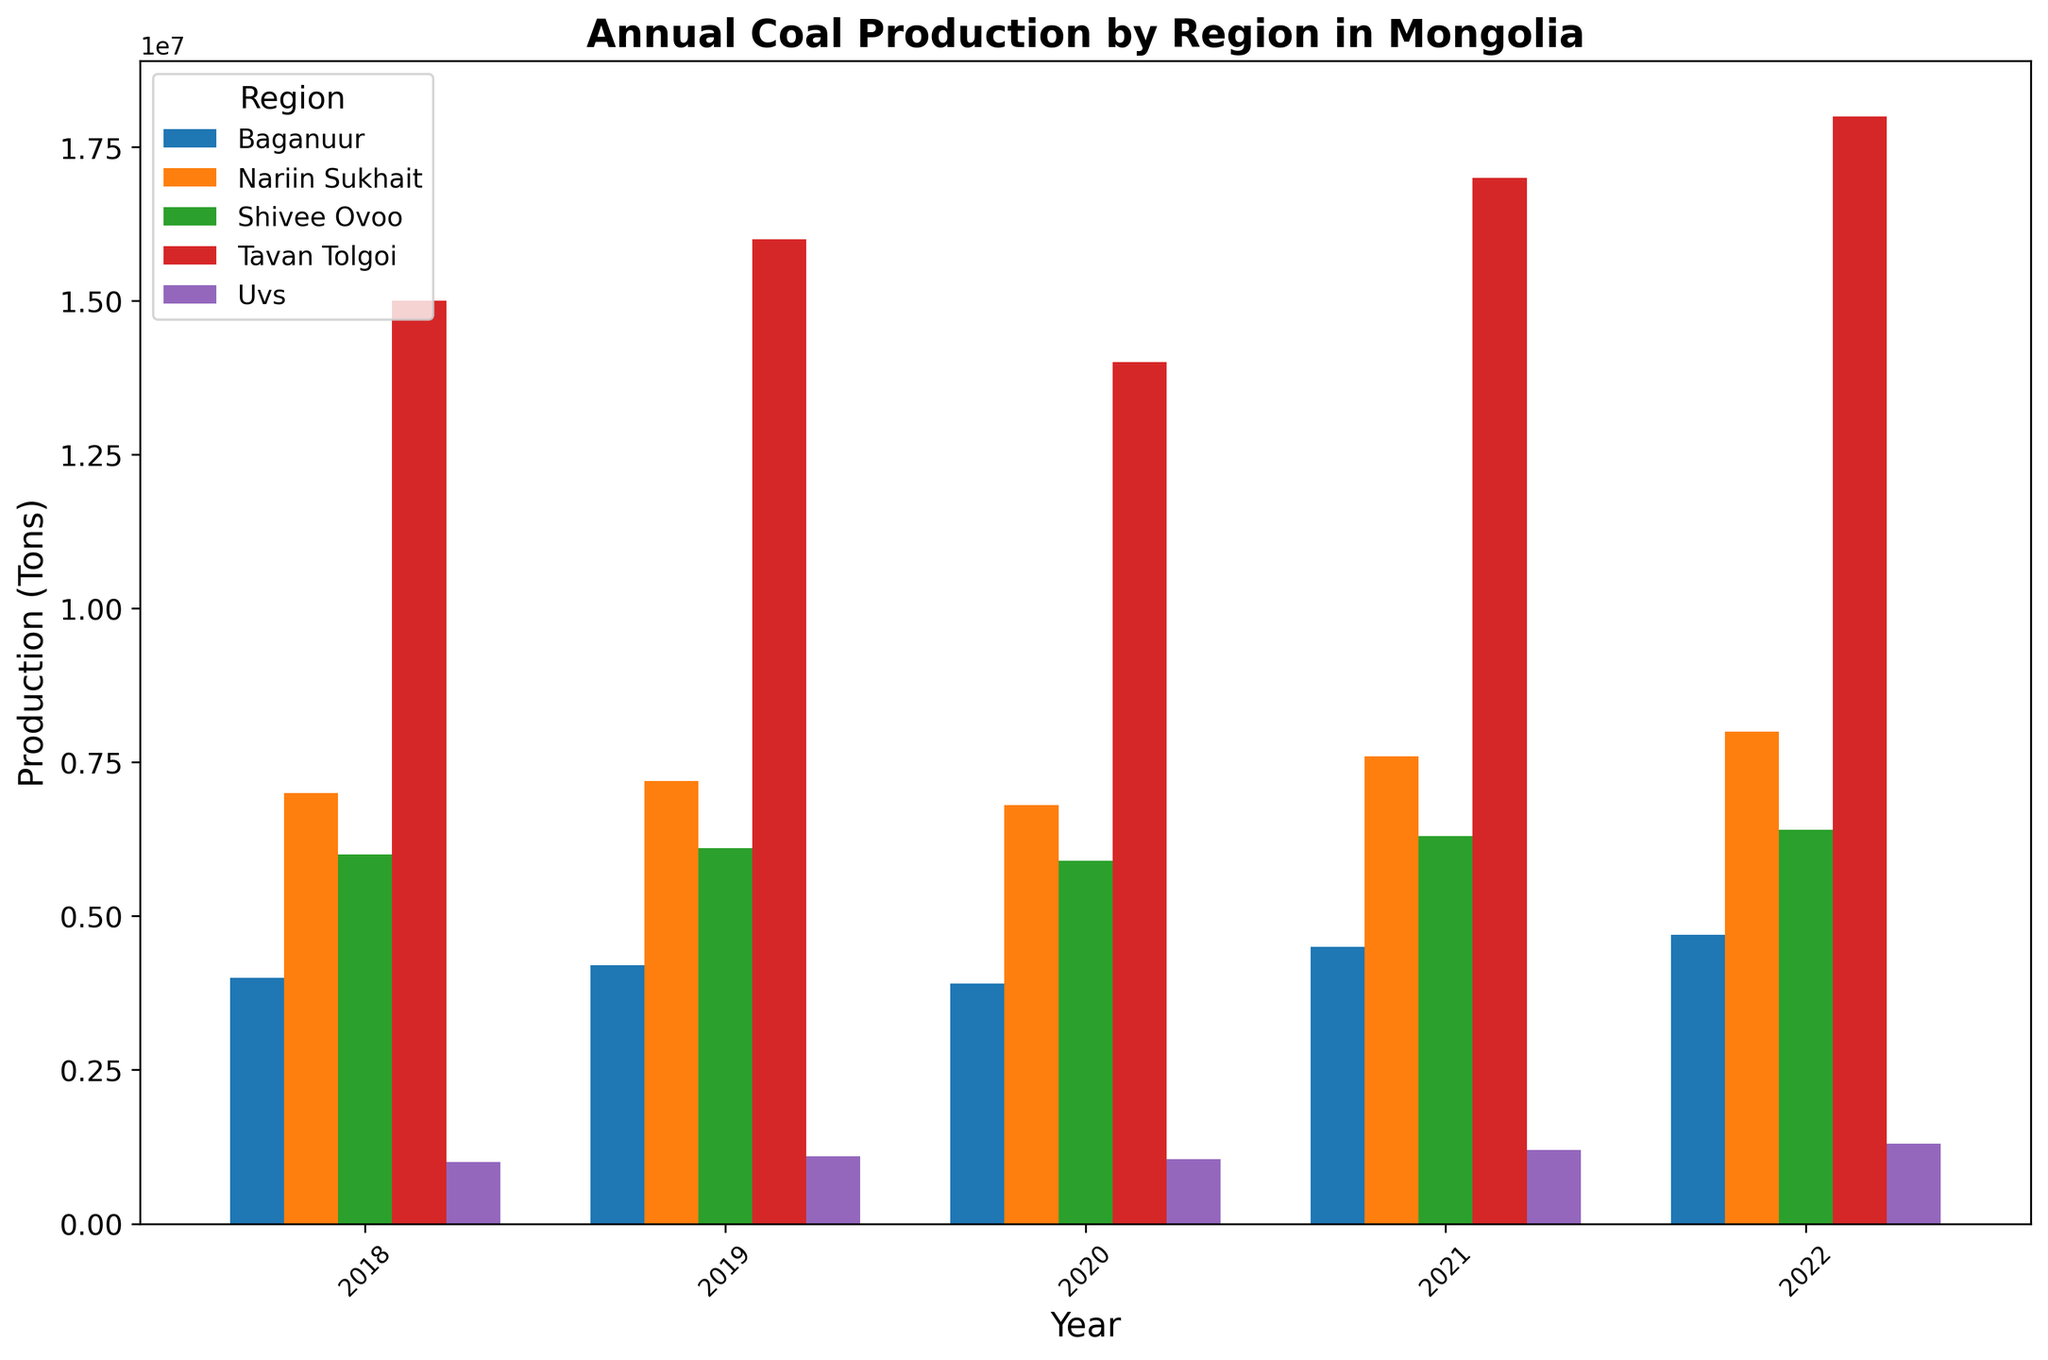What is the total coal production in Tavan Tolgoi for all years combined? To find the total production in Tavan Tolgoi, add the production values from each year: 15,000,000 + 16,000,000 + 14,000,000 + 17,000,000 + 18,000,000 = 80,000,000
Answer: 80,000,000 Which region had the highest coal production in 2022? Compare the coal production values of all regions in 2022. Tavan Tolgoi has the highest with 18,000,000 tons.
Answer: Tavan Tolgoi Was coal production in Baganuur higher in 2019 or in 2020? Check the production values for Baganuur in 2019 and 2020. 2019 had 4,200,000 tons and 2020 had 3,900,000 tons. Therefore, 2019 was higher.
Answer: 2019 How did coal production trend in Nariin Sukhait from 2018 to 2022? Observe the yearly production values for Nariin Sukhait: 7,000,000 in 2018, 7,200,000 in 2019, 6,800,000 in 2020, 7,600,000 in 2021, and 8,000,000 in 2022. The production shows an overall increasing trend.
Answer: Increasing What was the average annual coal production in Shivee Ovoo from 2018 to 2022? Calculate the average by adding the annual productions and then dividing by the number of years: (6,000,000 + 6,100,000 + 5,900,000 + 6,300,000 + 6,400,000) / 5 = 6,140,000
Answer: 6,140,000 Which year did Uvs region see its lowest coal production? Compare the coal production values in Uvs from each year. The lowest production was in 2018 with 1,000,000 tons.
Answer: 2018 Did all regions increase their coal production from 2018 to 2022? Check the production values for all regions in 2018 and compare them to 2022. All regions show increased production from 2018 to 2022.
Answer: Yes What is the difference in coal production between 2021 and 2022 for Tavan Tolgoi? Subtract the production value of 2021 from 2022: 18,000,000 - 17,000,000 = 1,000,000
Answer: 1,000,000 Which region had the smallest increase in coal production from 2018 to 2022? Calculate the increase for each region and compare: Tavan Tolgoi (3,000,000), Nariin Sukhait (1,000,000), Shivee Ovoo (400,000), Baganuur (700,000), Uvs (300,000). Uvs had the smallest increase of 300,000 tons.
Answer: Uvs 